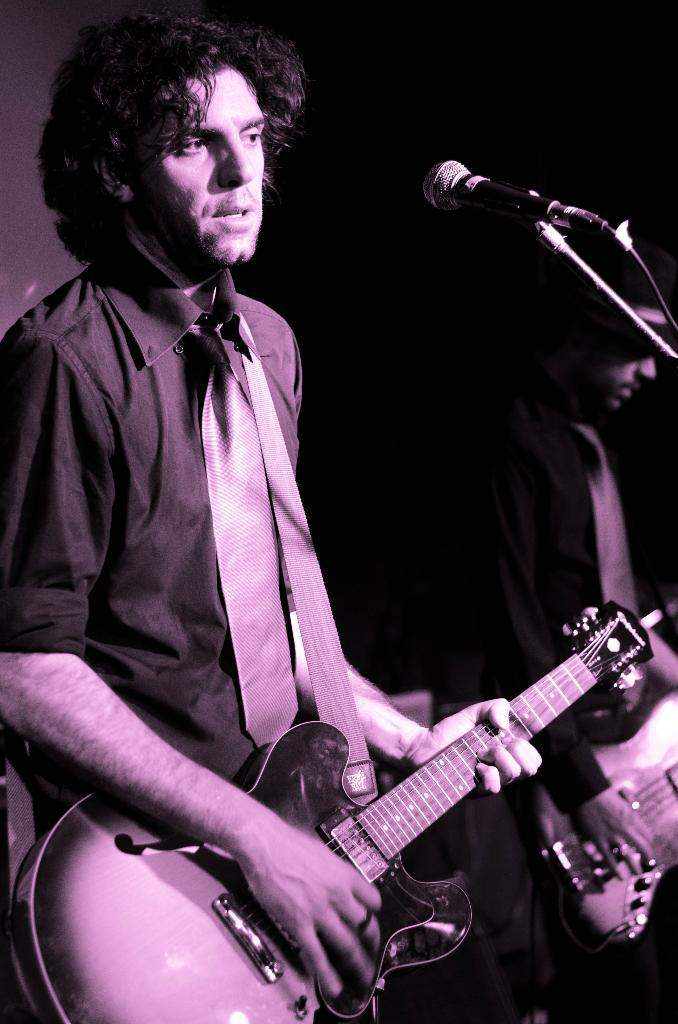How many people are in the image? There are two persons in the image. Where are the two persons located? The two persons are standing on a stage. What are the two persons doing on the stage? Both persons are playing musical instruments. What type of shade is being provided by the musical instruments in the image? There is no shade being provided by the musical instruments in the image, as they are being played by the two persons on the stage. 